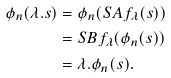Convert formula to latex. <formula><loc_0><loc_0><loc_500><loc_500>\phi _ { n } ( \lambda . s ) & = \phi _ { n } ( S A f _ { \lambda } ( s ) ) \\ & = S B f _ { \lambda } ( \phi _ { n } ( s ) ) \\ & = \lambda . \phi _ { n } ( s ) \text  .</formula> 